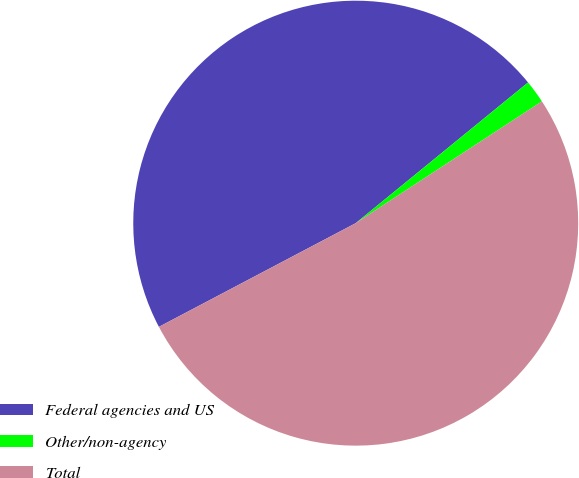Convert chart to OTSL. <chart><loc_0><loc_0><loc_500><loc_500><pie_chart><fcel>Federal agencies and US<fcel>Other/non-agency<fcel>Total<nl><fcel>46.82%<fcel>1.68%<fcel>51.5%<nl></chart> 